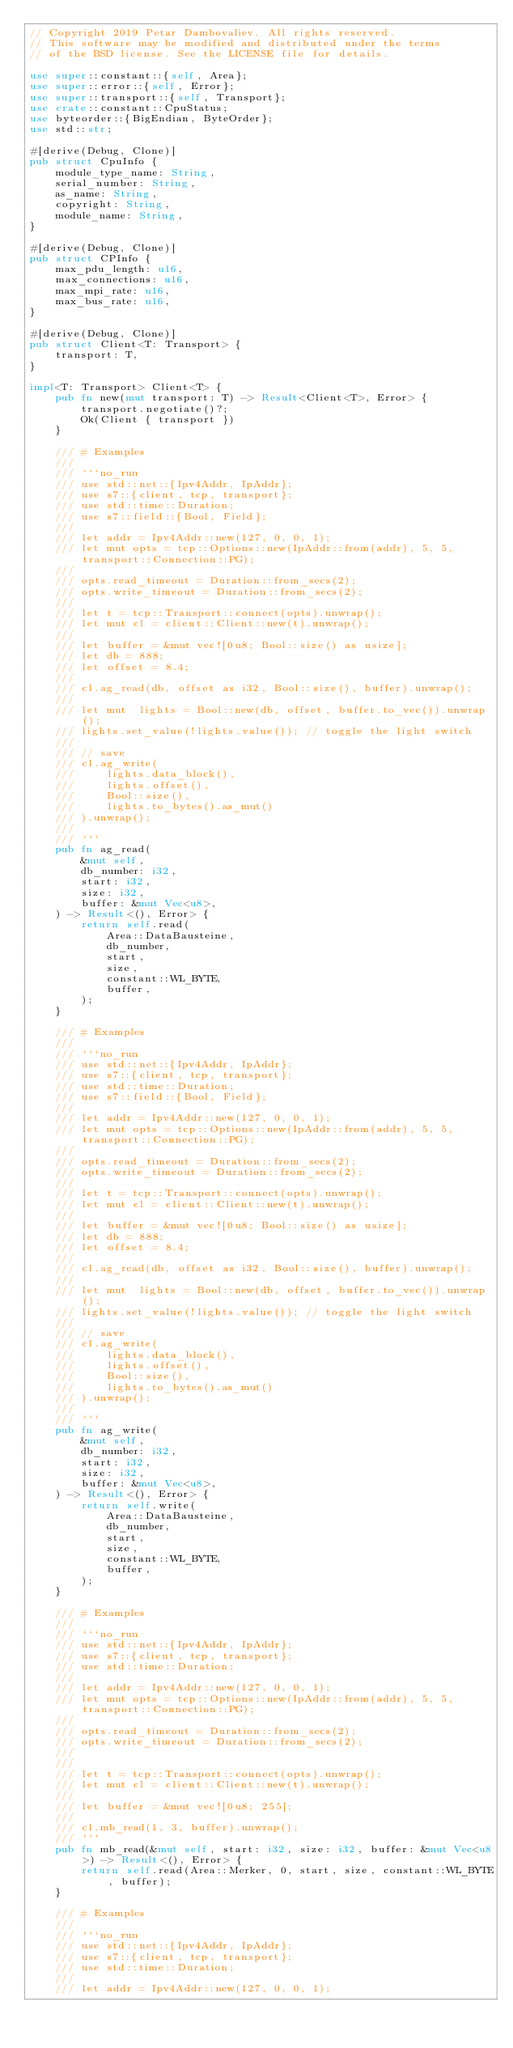Convert code to text. <code><loc_0><loc_0><loc_500><loc_500><_Rust_>// Copyright 2019 Petar Dambovaliev. All rights reserved.
// This software may be modified and distributed under the terms
// of the BSD license. See the LICENSE file for details.

use super::constant::{self, Area};
use super::error::{self, Error};
use super::transport::{self, Transport};
use crate::constant::CpuStatus;
use byteorder::{BigEndian, ByteOrder};
use std::str;

#[derive(Debug, Clone)]
pub struct CpuInfo {
    module_type_name: String,
    serial_number: String,
    as_name: String,
    copyright: String,
    module_name: String,
}

#[derive(Debug, Clone)]
pub struct CPInfo {
    max_pdu_length: u16,
    max_connections: u16,
    max_mpi_rate: u16,
    max_bus_rate: u16,
}

#[derive(Debug, Clone)]
pub struct Client<T: Transport> {
    transport: T,
}

impl<T: Transport> Client<T> {
    pub fn new(mut transport: T) -> Result<Client<T>, Error> {
        transport.negotiate()?;
        Ok(Client { transport })
    }

    /// # Examples
    ///
    /// ```no_run
    /// use std::net::{Ipv4Addr, IpAddr};
    /// use s7::{client, tcp, transport};
    /// use std::time::Duration;
    /// use s7::field::{Bool, Field};
    ///
    /// let addr = Ipv4Addr::new(127, 0, 0, 1);
    /// let mut opts = tcp::Options::new(IpAddr::from(addr), 5, 5, transport::Connection::PG);
    ///
    /// opts.read_timeout = Duration::from_secs(2);
    /// opts.write_timeout = Duration::from_secs(2);
    ///
    /// let t = tcp::Transport::connect(opts).unwrap();
    /// let mut cl = client::Client::new(t).unwrap();
    ///
    /// let buffer = &mut vec![0u8; Bool::size() as usize];
    /// let db = 888;
    /// let offset = 8.4;
    ///
    /// cl.ag_read(db, offset as i32, Bool::size(), buffer).unwrap();
    ///
    /// let mut  lights = Bool::new(db, offset, buffer.to_vec()).unwrap();
    /// lights.set_value(!lights.value()); // toggle the light switch
    ///
    /// // save
    /// cl.ag_write(
    ///     lights.data_block(),
    ///     lights.offset(),
    ///     Bool::size(),
    ///     lights.to_bytes().as_mut()
    /// ).unwrap();
    ///
    /// ```
    pub fn ag_read(
        &mut self,
        db_number: i32,
        start: i32,
        size: i32,
        buffer: &mut Vec<u8>,
    ) -> Result<(), Error> {
        return self.read(
            Area::DataBausteine,
            db_number,
            start,
            size,
            constant::WL_BYTE,
            buffer,
        );
    }

    /// # Examples
    ///
    /// ```no_run
    /// use std::net::{Ipv4Addr, IpAddr};
    /// use s7::{client, tcp, transport};
    /// use std::time::Duration;
    /// use s7::field::{Bool, Field};
    ///
    /// let addr = Ipv4Addr::new(127, 0, 0, 1);
    /// let mut opts = tcp::Options::new(IpAddr::from(addr), 5, 5, transport::Connection::PG);
    ///
    /// opts.read_timeout = Duration::from_secs(2);
    /// opts.write_timeout = Duration::from_secs(2);
    ///
    /// let t = tcp::Transport::connect(opts).unwrap();
    /// let mut cl = client::Client::new(t).unwrap();
    ///
    /// let buffer = &mut vec![0u8; Bool::size() as usize];
    /// let db = 888;
    /// let offset = 8.4;
    ///
    /// cl.ag_read(db, offset as i32, Bool::size(), buffer).unwrap();
    ///
    /// let mut  lights = Bool::new(db, offset, buffer.to_vec()).unwrap();
    /// lights.set_value(!lights.value()); // toggle the light switch
    ///
    /// // save
    /// cl.ag_write(
    ///     lights.data_block(),
    ///     lights.offset(),
    ///     Bool::size(),
    ///     lights.to_bytes().as_mut()
    /// ).unwrap();
    ///
    /// ```
    pub fn ag_write(
        &mut self,
        db_number: i32,
        start: i32,
        size: i32,
        buffer: &mut Vec<u8>,
    ) -> Result<(), Error> {
        return self.write(
            Area::DataBausteine,
            db_number,
            start,
            size,
            constant::WL_BYTE,
            buffer,
        );
    }

    /// # Examples
    ///
    /// ```no_run
    /// use std::net::{Ipv4Addr, IpAddr};
    /// use s7::{client, tcp, transport};
    /// use std::time::Duration;
    ///
    /// let addr = Ipv4Addr::new(127, 0, 0, 1);
    /// let mut opts = tcp::Options::new(IpAddr::from(addr), 5, 5, transport::Connection::PG);
    ///
    /// opts.read_timeout = Duration::from_secs(2);
    /// opts.write_timeout = Duration::from_secs(2);
    ///
    ///
    /// let t = tcp::Transport::connect(opts).unwrap();
    /// let mut cl = client::Client::new(t).unwrap();
    ///
    /// let buffer = &mut vec![0u8; 255];
    ///
    /// cl.mb_read(1, 3, buffer).unwrap();
    /// ```
    pub fn mb_read(&mut self, start: i32, size: i32, buffer: &mut Vec<u8>) -> Result<(), Error> {
        return self.read(Area::Merker, 0, start, size, constant::WL_BYTE, buffer);
    }

    /// # Examples
    ///
    /// ```no_run
    /// use std::net::{Ipv4Addr, IpAddr};
    /// use s7::{client, tcp, transport};
    /// use std::time::Duration;
    ///
    /// let addr = Ipv4Addr::new(127, 0, 0, 1);</code> 